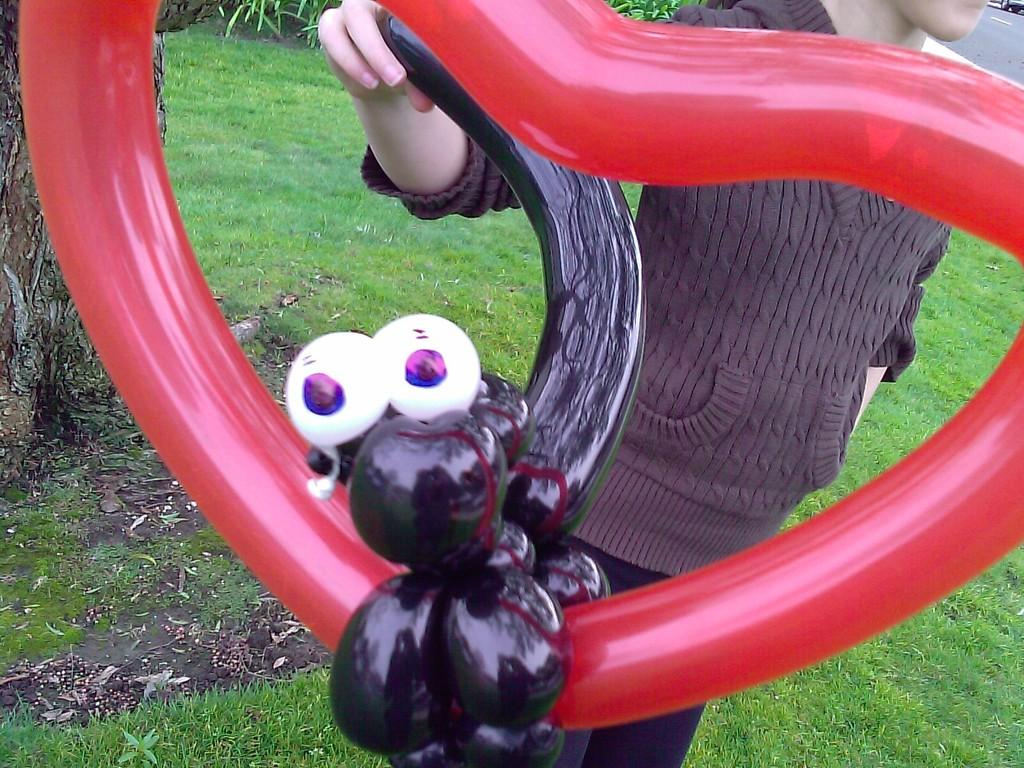What can be seen in the image? There is a person in the image. Can you describe the person's appearance? The person's face is not visible in the image. What is the person holding in the image? The person is holding a balloon. What is on the left side of the image? There is a stem on the left side of the image. What type of ground is visible in the image? There is grass on the ground. What is the person learning in the image? There is no indication in the image that the person is learning anything. 